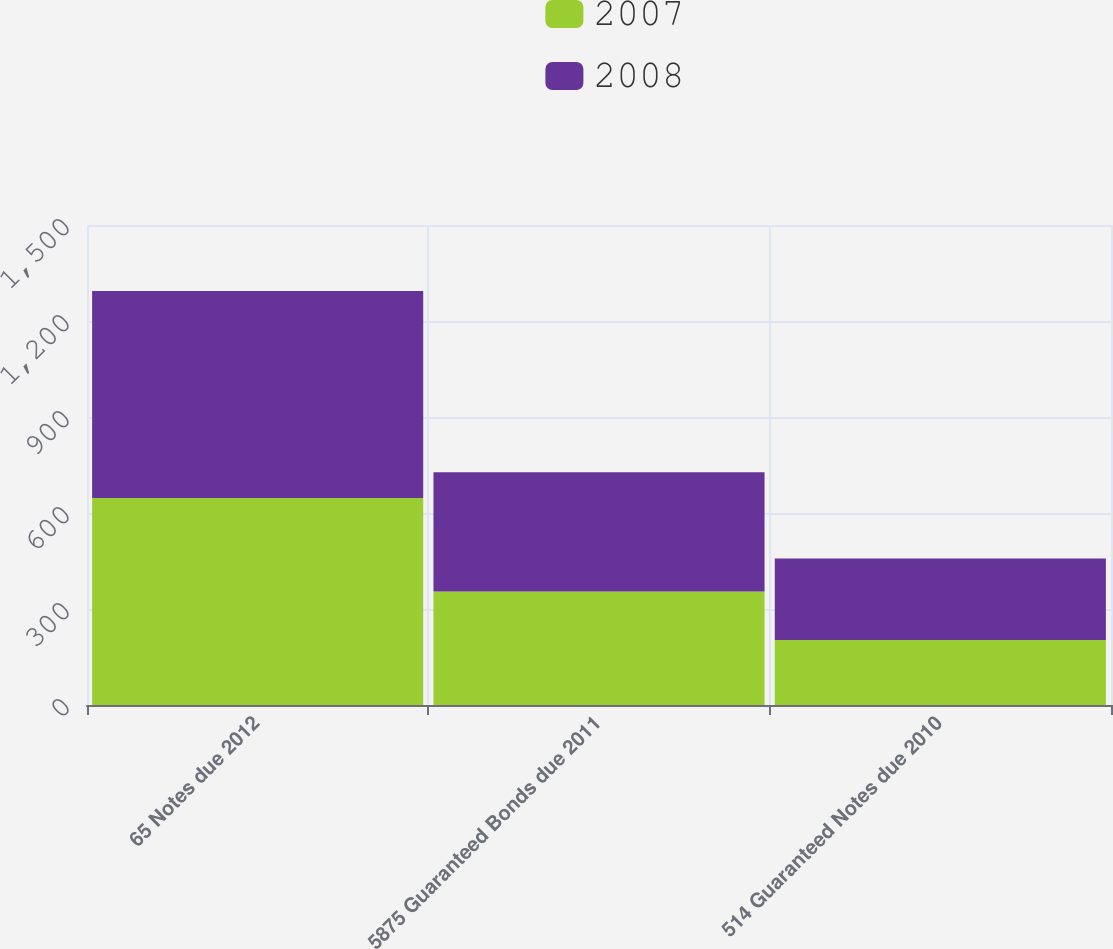Convert chart to OTSL. <chart><loc_0><loc_0><loc_500><loc_500><stacked_bar_chart><ecel><fcel>65 Notes due 2012<fcel>5875 Guaranteed Bonds due 2011<fcel>514 Guaranteed Notes due 2010<nl><fcel>2007<fcel>647<fcel>355<fcel>203<nl><fcel>2008<fcel>647<fcel>372<fcel>255<nl></chart> 